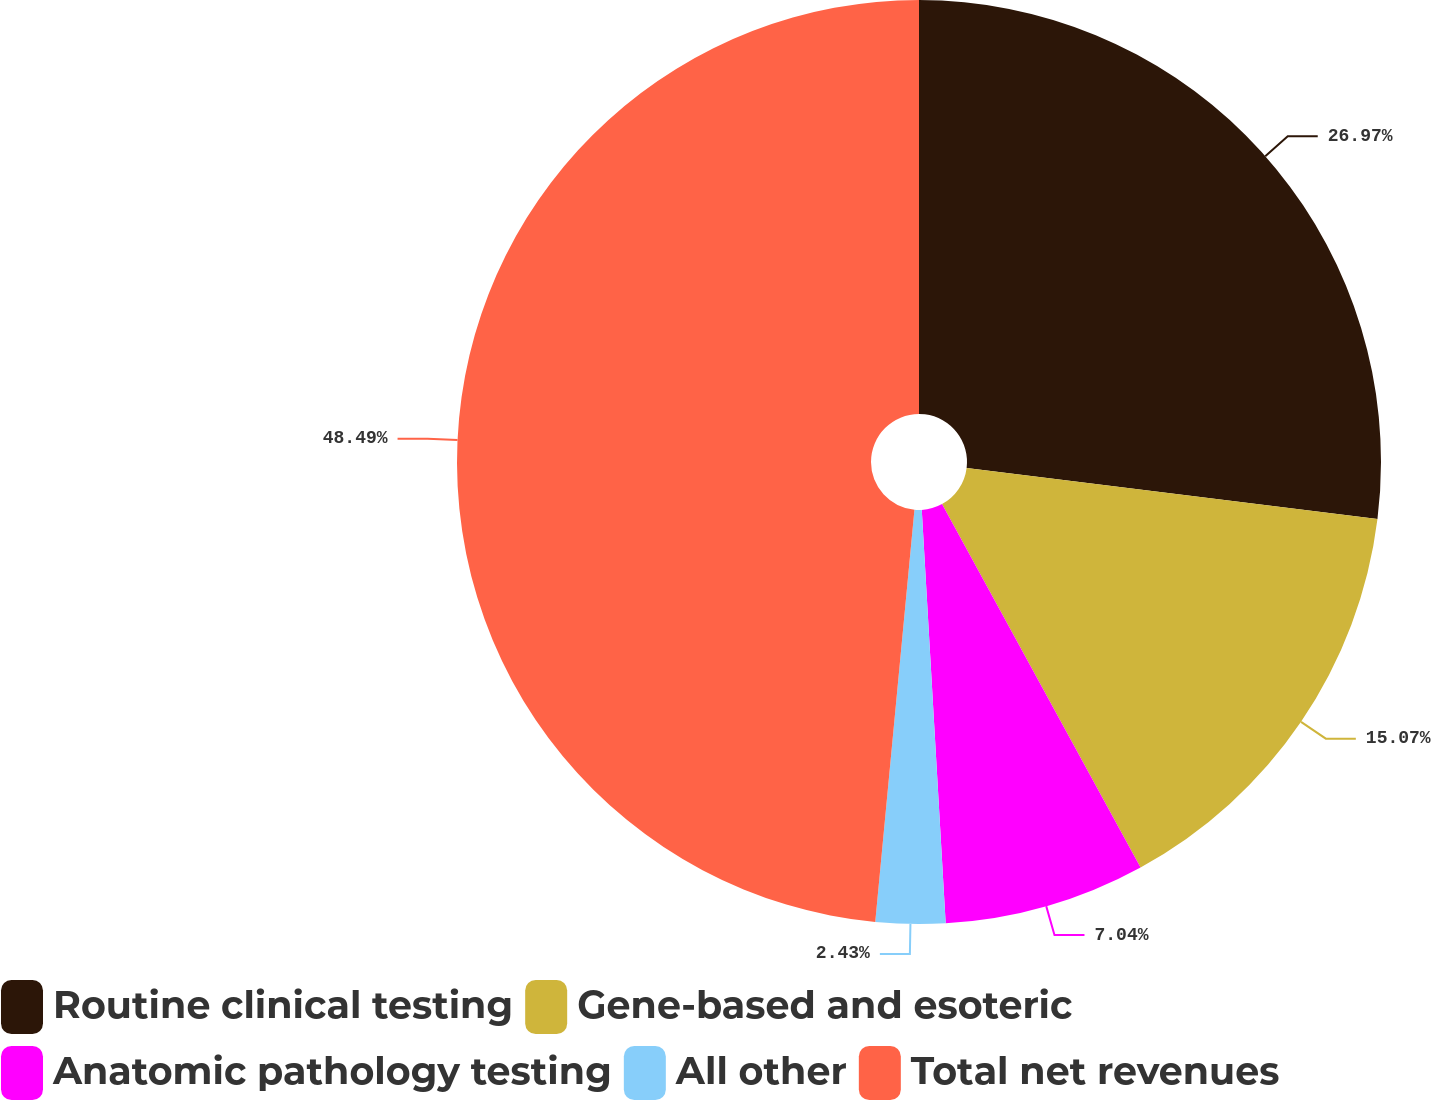Convert chart to OTSL. <chart><loc_0><loc_0><loc_500><loc_500><pie_chart><fcel>Routine clinical testing<fcel>Gene-based and esoteric<fcel>Anatomic pathology testing<fcel>All other<fcel>Total net revenues<nl><fcel>26.97%<fcel>15.07%<fcel>7.04%<fcel>2.43%<fcel>48.49%<nl></chart> 